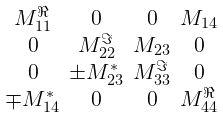<formula> <loc_0><loc_0><loc_500><loc_500>\begin{smallmatrix} \\ M _ { 1 1 } ^ { \Re } & 0 & 0 & M _ { 1 4 } \\ 0 & M _ { 2 2 } ^ { \Im } & M _ { 2 3 } & 0 \\ 0 & \pm M _ { 2 3 } ^ { * } & M _ { 3 3 } ^ { \Im } & 0 \\ \mp M _ { 1 4 } ^ { * } & 0 & 0 & M _ { 4 4 } ^ { \Re } \\ \end{smallmatrix}</formula> 